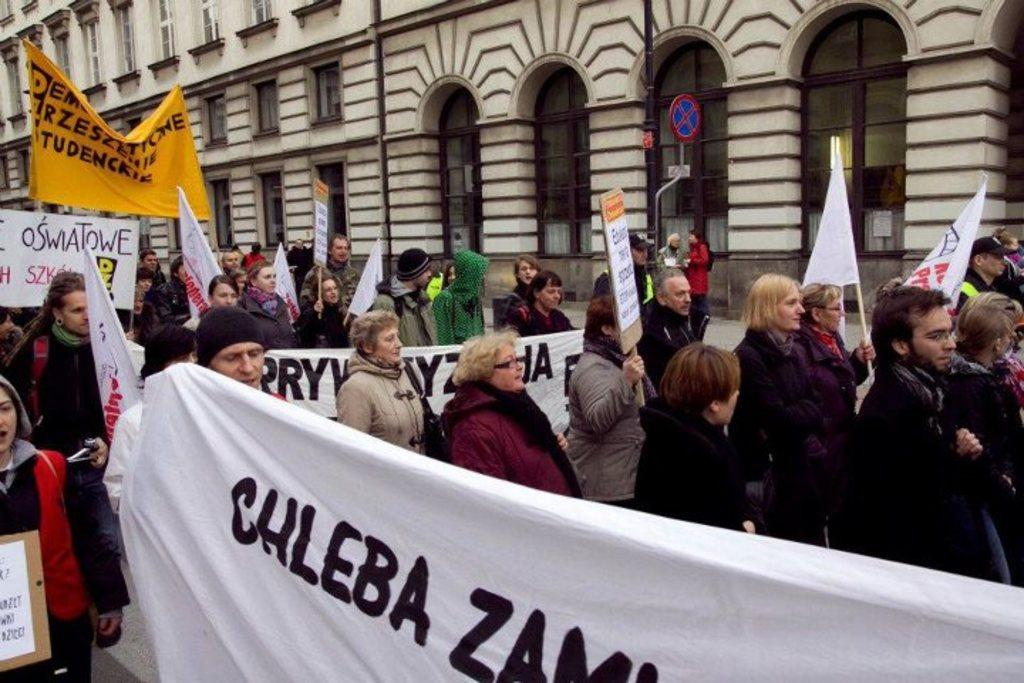What decorative items can be seen in the image? There are banners and flags in the image. Who or what is present in the image? There are people in the image. What type of structures are visible in the image? There are buildings in the image. What architectural feature can be seen in the buildings? There are windows in the image. Can you see any fish being used as bait in the image? There is no mention of fish or bait in the image; it features banners, flags, people, buildings, and windows. 